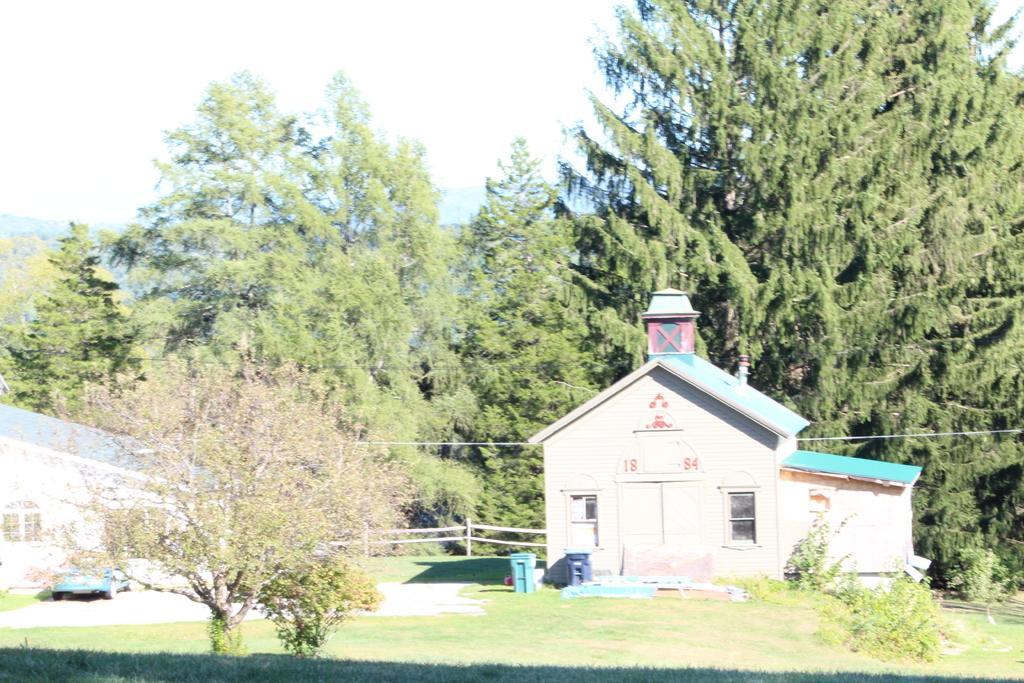Can you describe this image briefly? In this image we can see wooden houses, car parked here, we can see grassland, trees, trash cans, wires, fence, trees and the sky in the background. 